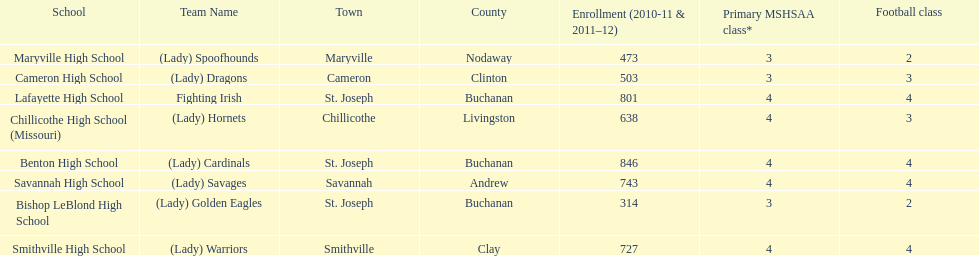Which school has the largest enrollment? Benton High School. 